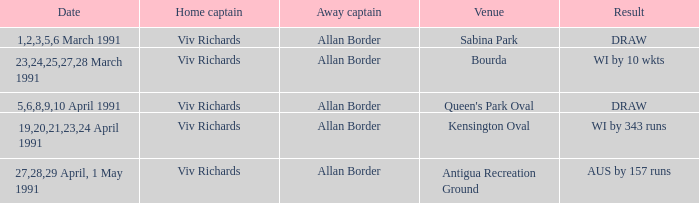What were the dates of matches taking place at sabina park? 1,2,3,5,6 March 1991. I'm looking to parse the entire table for insights. Could you assist me with that? {'header': ['Date', 'Home captain', 'Away captain', 'Venue', 'Result'], 'rows': [['1,2,3,5,6 March 1991', 'Viv Richards', 'Allan Border', 'Sabina Park', 'DRAW'], ['23,24,25,27,28 March 1991', 'Viv Richards', 'Allan Border', 'Bourda', 'WI by 10 wkts'], ['5,6,8,9,10 April 1991', 'Viv Richards', 'Allan Border', "Queen's Park Oval", 'DRAW'], ['19,20,21,23,24 April 1991', 'Viv Richards', 'Allan Border', 'Kensington Oval', 'WI by 343 runs'], ['27,28,29 April, 1 May 1991', 'Viv Richards', 'Allan Border', 'Antigua Recreation Ground', 'AUS by 157 runs']]} 